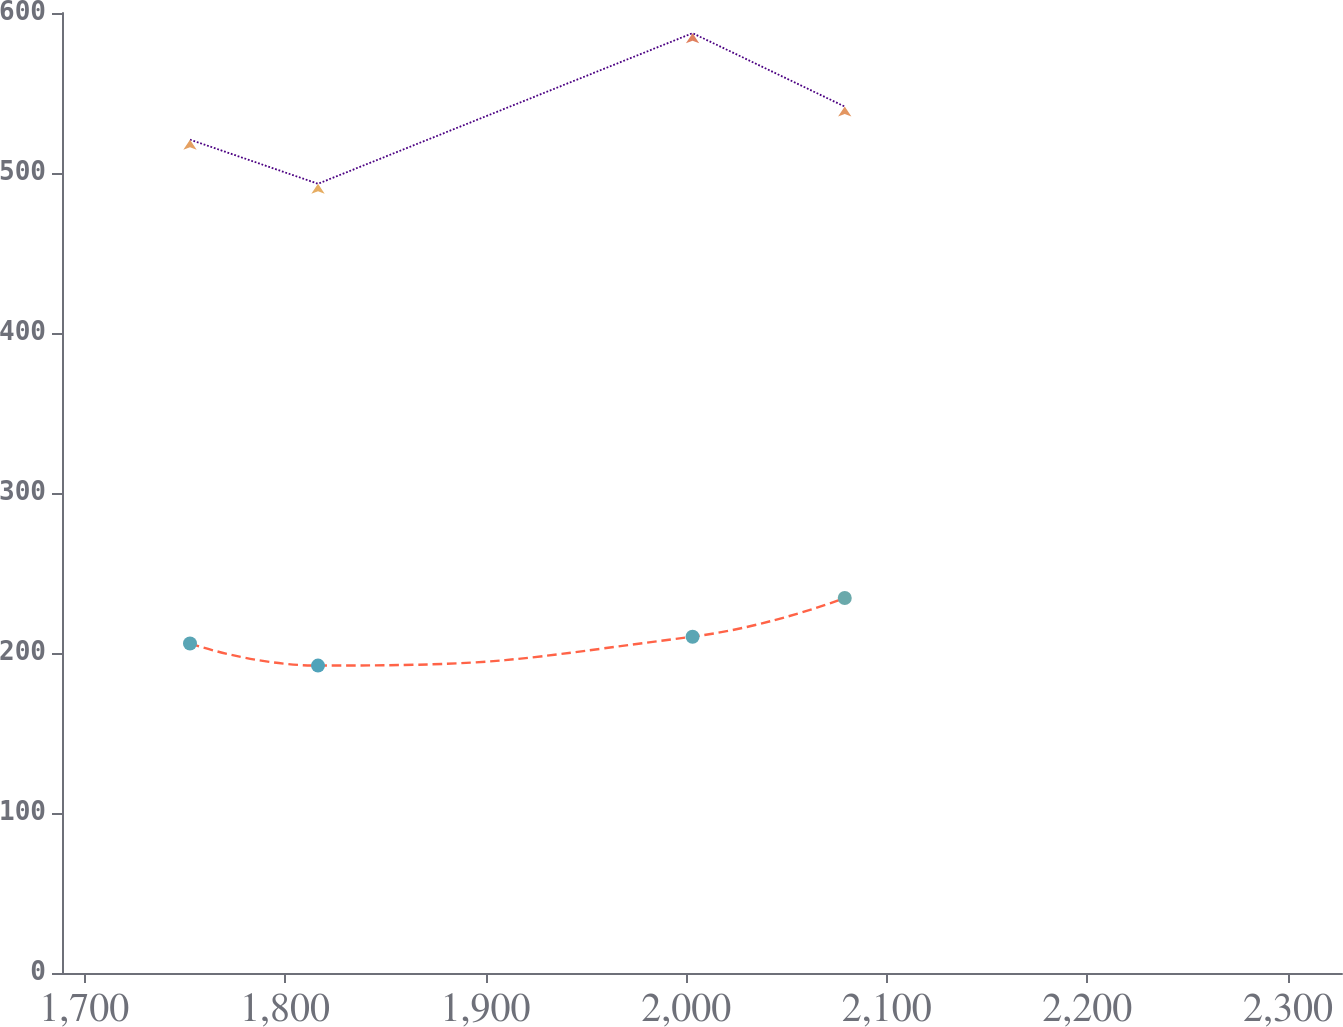Convert chart. <chart><loc_0><loc_0><loc_500><loc_500><line_chart><ecel><fcel>Other<fcel>Pension<nl><fcel>1752.67<fcel>520.85<fcel>205.98<nl><fcel>1816.48<fcel>493.28<fcel>192.14<nl><fcel>2003.2<fcel>587.39<fcel>210.2<nl><fcel>2079.05<fcel>541.52<fcel>234.38<nl><fcel>2390.74<fcel>689.27<fcel>214.42<nl></chart> 